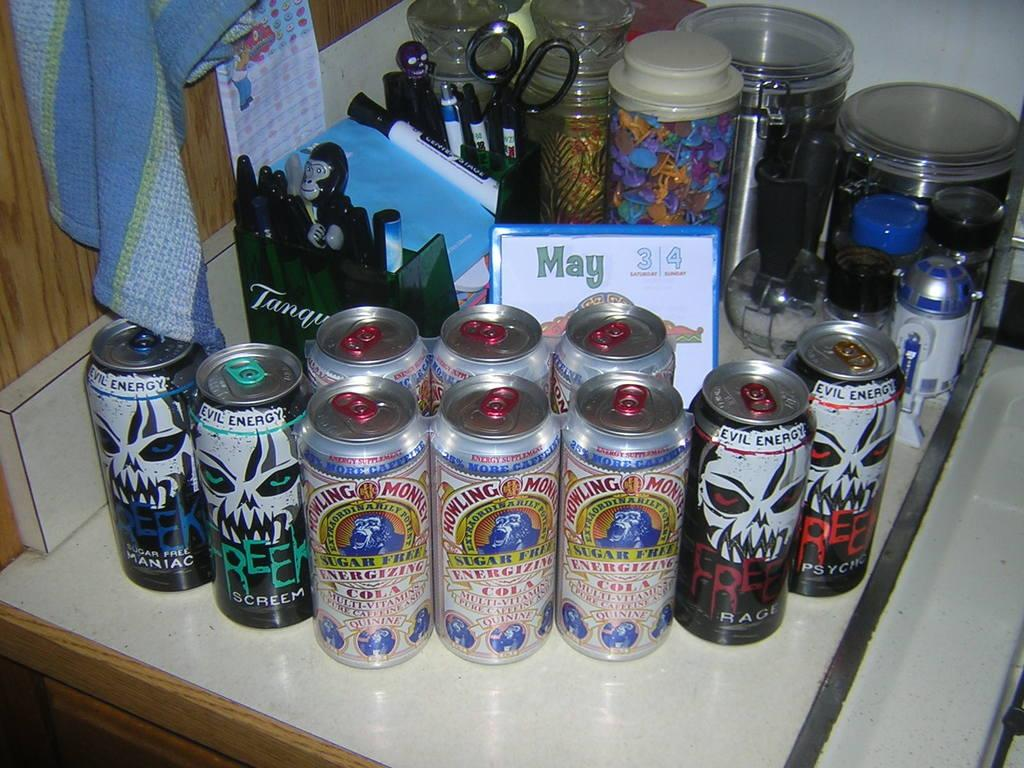Provide a one-sentence caption for the provided image. Several cans of beer sit on a counter on the weekend of May 3rd and 4th. 